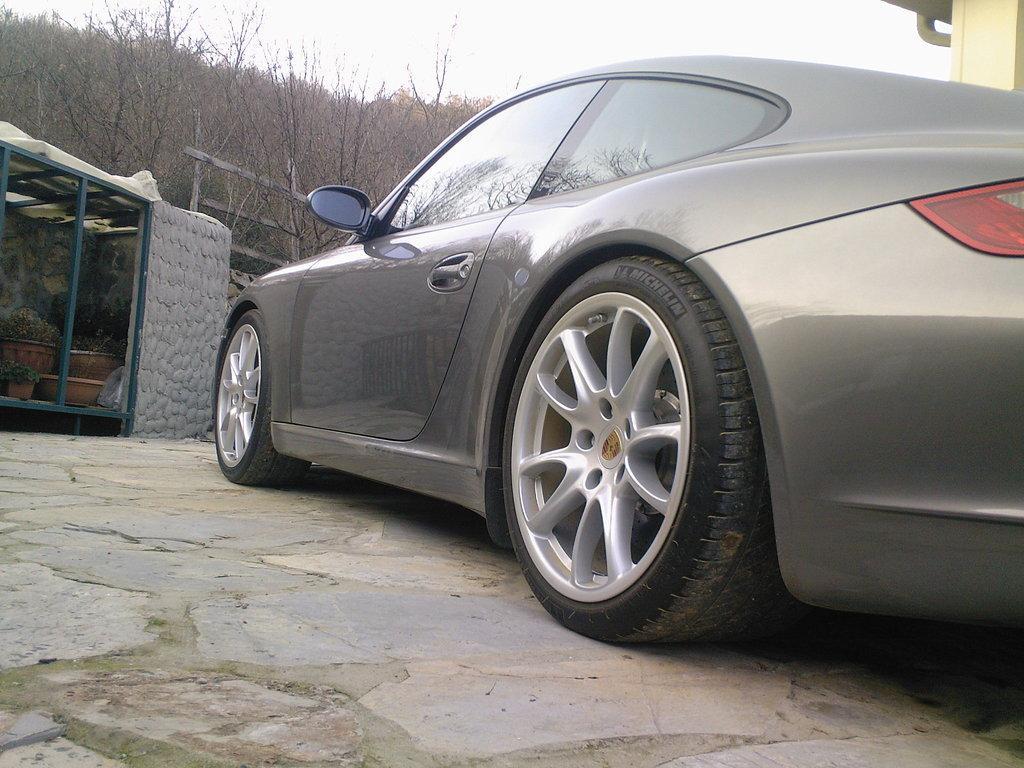In one or two sentences, can you explain what this image depicts? In this image we can see a motor vehicle on the floor, house plants, shade, trees and sky. 